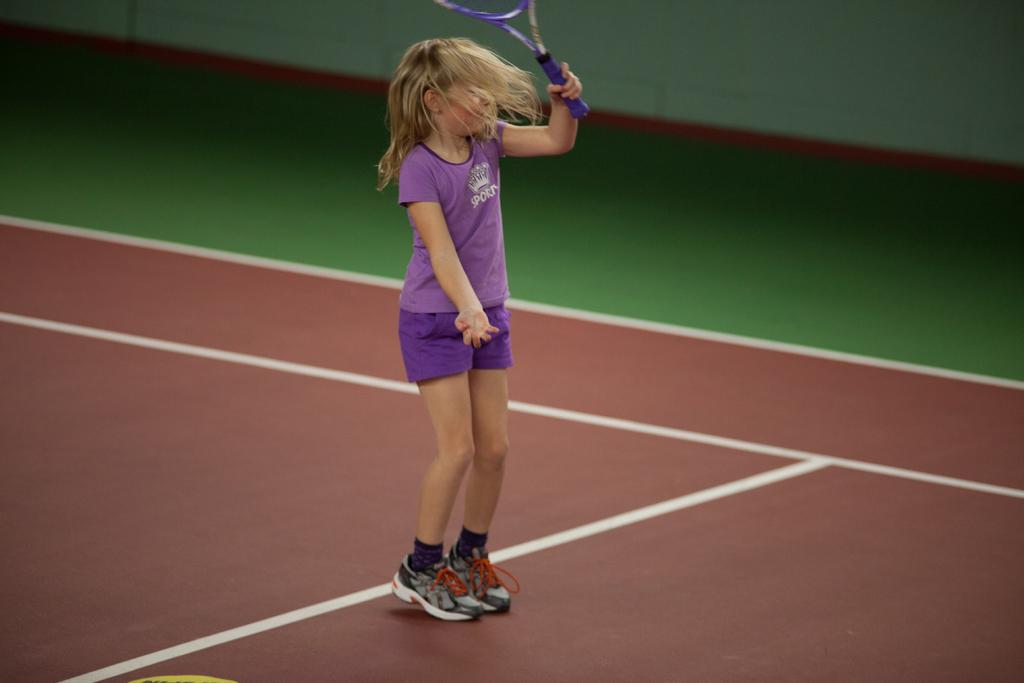What is the main subject of the image? The main subject of the image is a child. What is the child doing in the image? The child is standing on the ground. What object is the child holding in the image? The child is holding a racket. What type of bath is the child taking in the image? There is no bath present in the image; the child is standing on the ground holding a racket. What type of secretary is assisting the child in the image? There is no secretary present in the image; the child is standing on the ground holding a racket. 